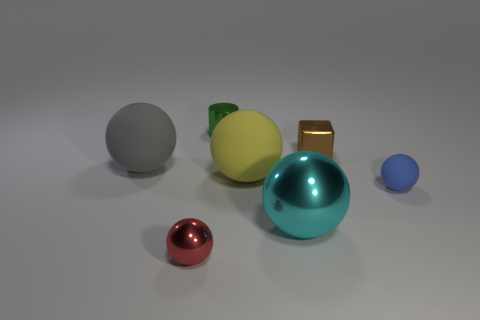What is the shape of the small metallic thing right of the big yellow rubber thing that is to the right of the tiny green metallic cylinder?
Your response must be concise. Cube. Do the metallic cylinder behind the yellow matte sphere and the rubber sphere that is to the right of the cyan ball have the same size?
Offer a very short reply. Yes. Is there a small blue thing that has the same material as the gray sphere?
Your answer should be very brief. Yes. Is there a blue rubber object behind the large matte sphere in front of the sphere behind the large yellow sphere?
Make the answer very short. No. Are there any tiny metallic blocks behind the small brown thing?
Offer a very short reply. No. What number of big spheres are in front of the big rubber thing right of the large gray ball?
Your response must be concise. 1. There is a gray rubber object; is its size the same as the yellow matte ball behind the tiny blue thing?
Offer a terse response. Yes. There is a sphere that is made of the same material as the small red object; what size is it?
Provide a succinct answer. Large. Is the red sphere made of the same material as the gray thing?
Offer a terse response. No. What is the color of the tiny thing that is to the right of the small metallic object on the right side of the large object in front of the blue rubber sphere?
Provide a succinct answer. Blue. 